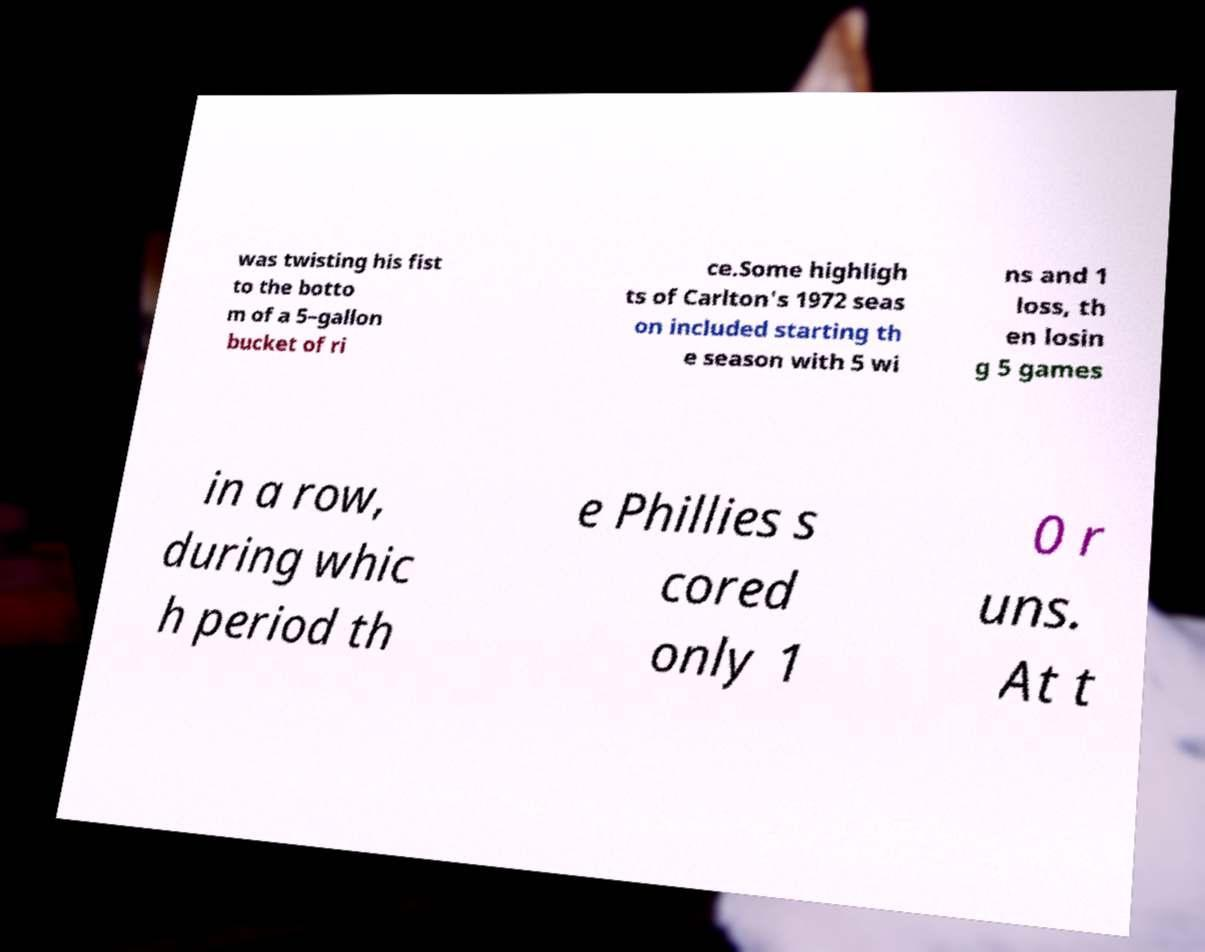Could you extract and type out the text from this image? was twisting his fist to the botto m of a 5–gallon bucket of ri ce.Some highligh ts of Carlton's 1972 seas on included starting th e season with 5 wi ns and 1 loss, th en losin g 5 games in a row, during whic h period th e Phillies s cored only 1 0 r uns. At t 